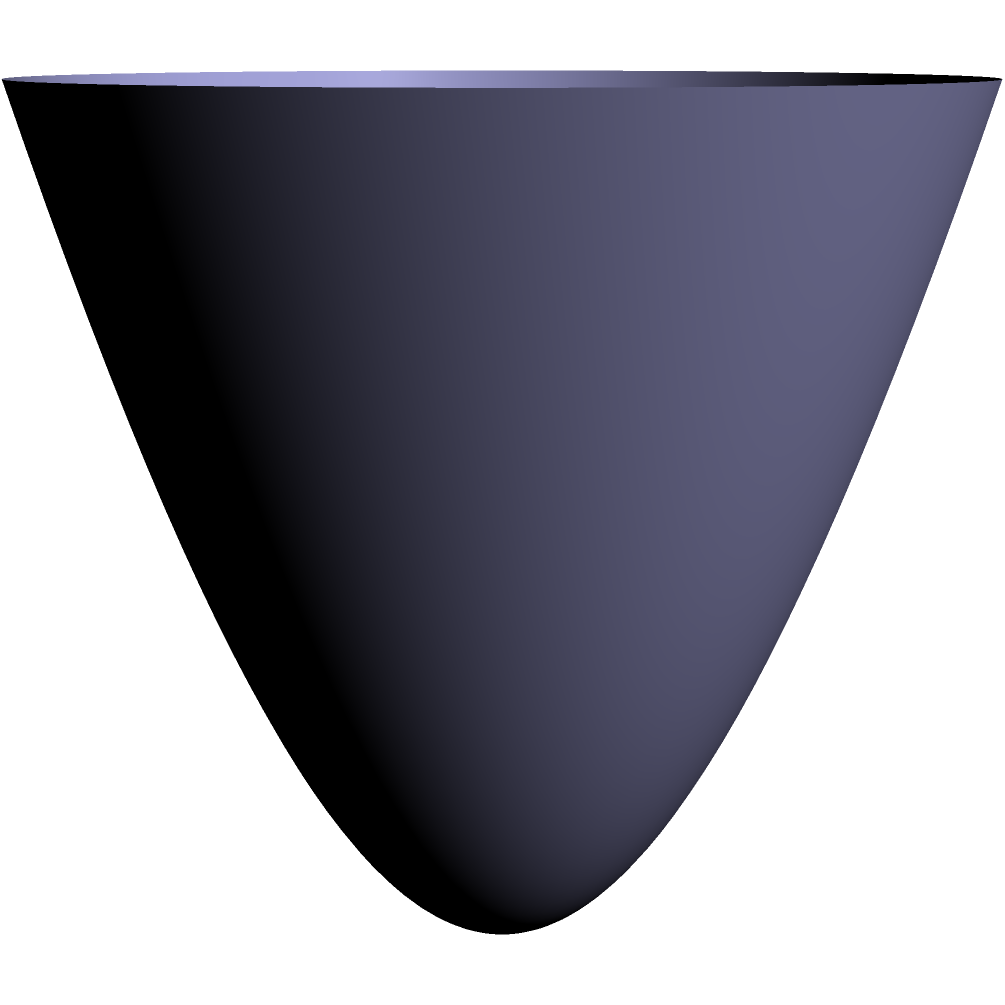As a brooding painter, you're commissioned to cover a twisted cone sculpture with a layer of paint. The sculpture's height is 2 units, and its base radius is 1 unit. The surface area of the sculpture is given by the formula:

$$ A = \int_0^1 2\pi r \sqrt{1 + 4r^2} dr $$

If you need to apply a layer of paint with a thickness of 0.01 units, what volume of paint (in cubic units) do you need? Round your answer to three decimal places. To solve this problem, we'll follow these steps:

1) First, we need to calculate the surface area of the sculpture:
   $$ A = \int_0^1 2\pi r \sqrt{1 + 4r^2} dr $$

2) This integral is complex, so we'll use a numerical integration method. Using a calculator or computer algebra system, we get:
   $$ A \approx 7.0258 \text{ square units} $$

3) Now, we need to calculate the volume of paint needed. The volume will be the surface area multiplied by the thickness of the paint:
   $$ V = A \times \text{thickness} $$

4) Substituting our values:
   $$ V = 7.0258 \times 0.01 = 0.070258 \text{ cubic units} $$

5) Rounding to three decimal places:
   $$ V \approx 0.070 \text{ cubic units} $$

This amount of paint will cover the entire surface of the twisted cone sculpture with a layer 0.01 units thick.
Answer: 0.070 cubic units 